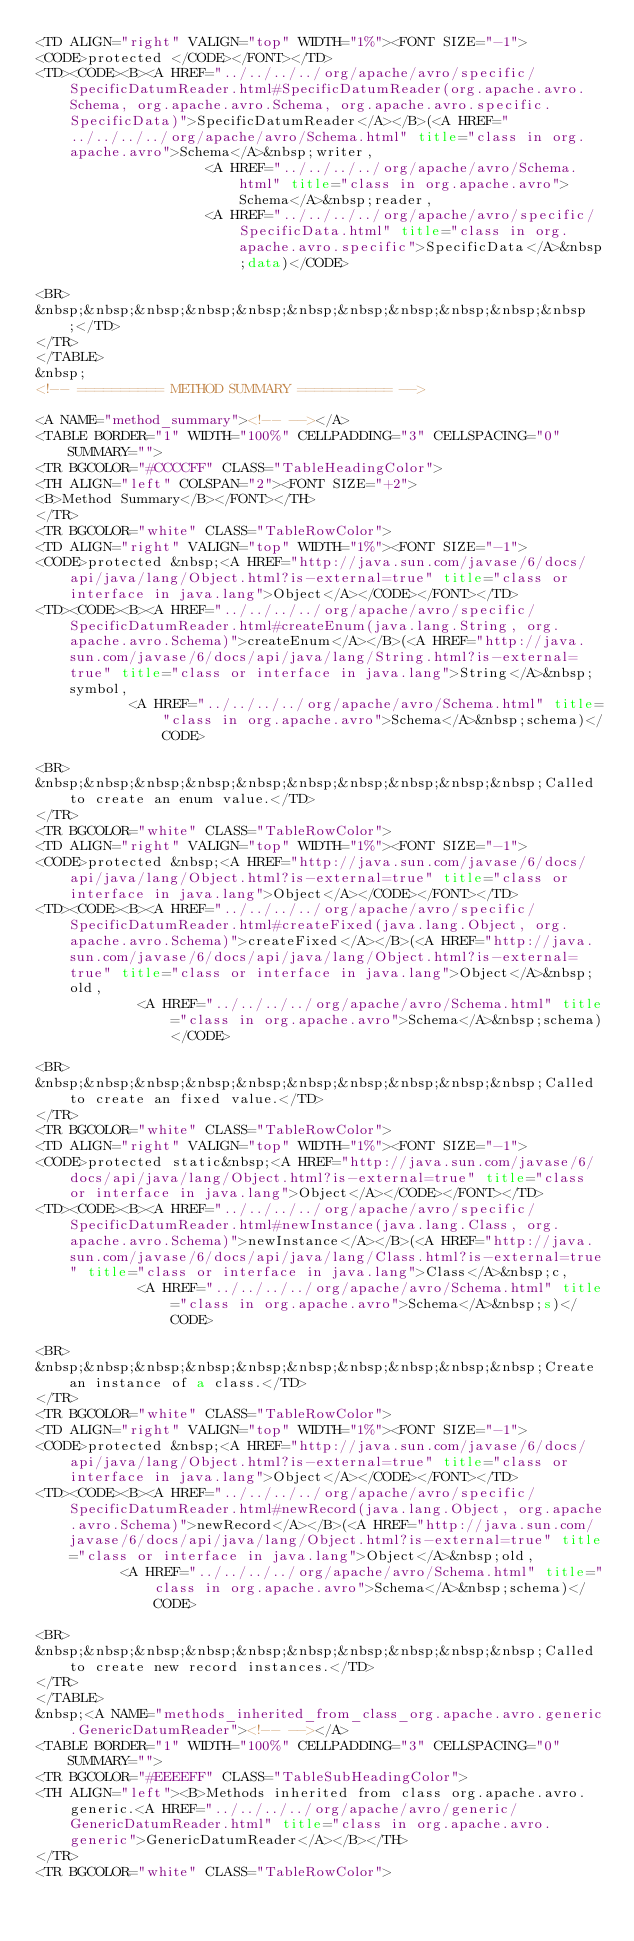Convert code to text. <code><loc_0><loc_0><loc_500><loc_500><_HTML_><TD ALIGN="right" VALIGN="top" WIDTH="1%"><FONT SIZE="-1">
<CODE>protected </CODE></FONT></TD>
<TD><CODE><B><A HREF="../../../../org/apache/avro/specific/SpecificDatumReader.html#SpecificDatumReader(org.apache.avro.Schema, org.apache.avro.Schema, org.apache.avro.specific.SpecificData)">SpecificDatumReader</A></B>(<A HREF="../../../../org/apache/avro/Schema.html" title="class in org.apache.avro">Schema</A>&nbsp;writer,
                    <A HREF="../../../../org/apache/avro/Schema.html" title="class in org.apache.avro">Schema</A>&nbsp;reader,
                    <A HREF="../../../../org/apache/avro/specific/SpecificData.html" title="class in org.apache.avro.specific">SpecificData</A>&nbsp;data)</CODE>

<BR>
&nbsp;&nbsp;&nbsp;&nbsp;&nbsp;&nbsp;&nbsp;&nbsp;&nbsp;&nbsp;&nbsp;</TD>
</TR>
</TABLE>
&nbsp;
<!-- ========== METHOD SUMMARY =========== -->

<A NAME="method_summary"><!-- --></A>
<TABLE BORDER="1" WIDTH="100%" CELLPADDING="3" CELLSPACING="0" SUMMARY="">
<TR BGCOLOR="#CCCCFF" CLASS="TableHeadingColor">
<TH ALIGN="left" COLSPAN="2"><FONT SIZE="+2">
<B>Method Summary</B></FONT></TH>
</TR>
<TR BGCOLOR="white" CLASS="TableRowColor">
<TD ALIGN="right" VALIGN="top" WIDTH="1%"><FONT SIZE="-1">
<CODE>protected &nbsp;<A HREF="http://java.sun.com/javase/6/docs/api/java/lang/Object.html?is-external=true" title="class or interface in java.lang">Object</A></CODE></FONT></TD>
<TD><CODE><B><A HREF="../../../../org/apache/avro/specific/SpecificDatumReader.html#createEnum(java.lang.String, org.apache.avro.Schema)">createEnum</A></B>(<A HREF="http://java.sun.com/javase/6/docs/api/java/lang/String.html?is-external=true" title="class or interface in java.lang">String</A>&nbsp;symbol,
           <A HREF="../../../../org/apache/avro/Schema.html" title="class in org.apache.avro">Schema</A>&nbsp;schema)</CODE>

<BR>
&nbsp;&nbsp;&nbsp;&nbsp;&nbsp;&nbsp;&nbsp;&nbsp;&nbsp;&nbsp;Called to create an enum value.</TD>
</TR>
<TR BGCOLOR="white" CLASS="TableRowColor">
<TD ALIGN="right" VALIGN="top" WIDTH="1%"><FONT SIZE="-1">
<CODE>protected &nbsp;<A HREF="http://java.sun.com/javase/6/docs/api/java/lang/Object.html?is-external=true" title="class or interface in java.lang">Object</A></CODE></FONT></TD>
<TD><CODE><B><A HREF="../../../../org/apache/avro/specific/SpecificDatumReader.html#createFixed(java.lang.Object, org.apache.avro.Schema)">createFixed</A></B>(<A HREF="http://java.sun.com/javase/6/docs/api/java/lang/Object.html?is-external=true" title="class or interface in java.lang">Object</A>&nbsp;old,
            <A HREF="../../../../org/apache/avro/Schema.html" title="class in org.apache.avro">Schema</A>&nbsp;schema)</CODE>

<BR>
&nbsp;&nbsp;&nbsp;&nbsp;&nbsp;&nbsp;&nbsp;&nbsp;&nbsp;&nbsp;Called to create an fixed value.</TD>
</TR>
<TR BGCOLOR="white" CLASS="TableRowColor">
<TD ALIGN="right" VALIGN="top" WIDTH="1%"><FONT SIZE="-1">
<CODE>protected static&nbsp;<A HREF="http://java.sun.com/javase/6/docs/api/java/lang/Object.html?is-external=true" title="class or interface in java.lang">Object</A></CODE></FONT></TD>
<TD><CODE><B><A HREF="../../../../org/apache/avro/specific/SpecificDatumReader.html#newInstance(java.lang.Class, org.apache.avro.Schema)">newInstance</A></B>(<A HREF="http://java.sun.com/javase/6/docs/api/java/lang/Class.html?is-external=true" title="class or interface in java.lang">Class</A>&nbsp;c,
            <A HREF="../../../../org/apache/avro/Schema.html" title="class in org.apache.avro">Schema</A>&nbsp;s)</CODE>

<BR>
&nbsp;&nbsp;&nbsp;&nbsp;&nbsp;&nbsp;&nbsp;&nbsp;&nbsp;&nbsp;Create an instance of a class.</TD>
</TR>
<TR BGCOLOR="white" CLASS="TableRowColor">
<TD ALIGN="right" VALIGN="top" WIDTH="1%"><FONT SIZE="-1">
<CODE>protected &nbsp;<A HREF="http://java.sun.com/javase/6/docs/api/java/lang/Object.html?is-external=true" title="class or interface in java.lang">Object</A></CODE></FONT></TD>
<TD><CODE><B><A HREF="../../../../org/apache/avro/specific/SpecificDatumReader.html#newRecord(java.lang.Object, org.apache.avro.Schema)">newRecord</A></B>(<A HREF="http://java.sun.com/javase/6/docs/api/java/lang/Object.html?is-external=true" title="class or interface in java.lang">Object</A>&nbsp;old,
          <A HREF="../../../../org/apache/avro/Schema.html" title="class in org.apache.avro">Schema</A>&nbsp;schema)</CODE>

<BR>
&nbsp;&nbsp;&nbsp;&nbsp;&nbsp;&nbsp;&nbsp;&nbsp;&nbsp;&nbsp;Called to create new record instances.</TD>
</TR>
</TABLE>
&nbsp;<A NAME="methods_inherited_from_class_org.apache.avro.generic.GenericDatumReader"><!-- --></A>
<TABLE BORDER="1" WIDTH="100%" CELLPADDING="3" CELLSPACING="0" SUMMARY="">
<TR BGCOLOR="#EEEEFF" CLASS="TableSubHeadingColor">
<TH ALIGN="left"><B>Methods inherited from class org.apache.avro.generic.<A HREF="../../../../org/apache/avro/generic/GenericDatumReader.html" title="class in org.apache.avro.generic">GenericDatumReader</A></B></TH>
</TR>
<TR BGCOLOR="white" CLASS="TableRowColor"></code> 